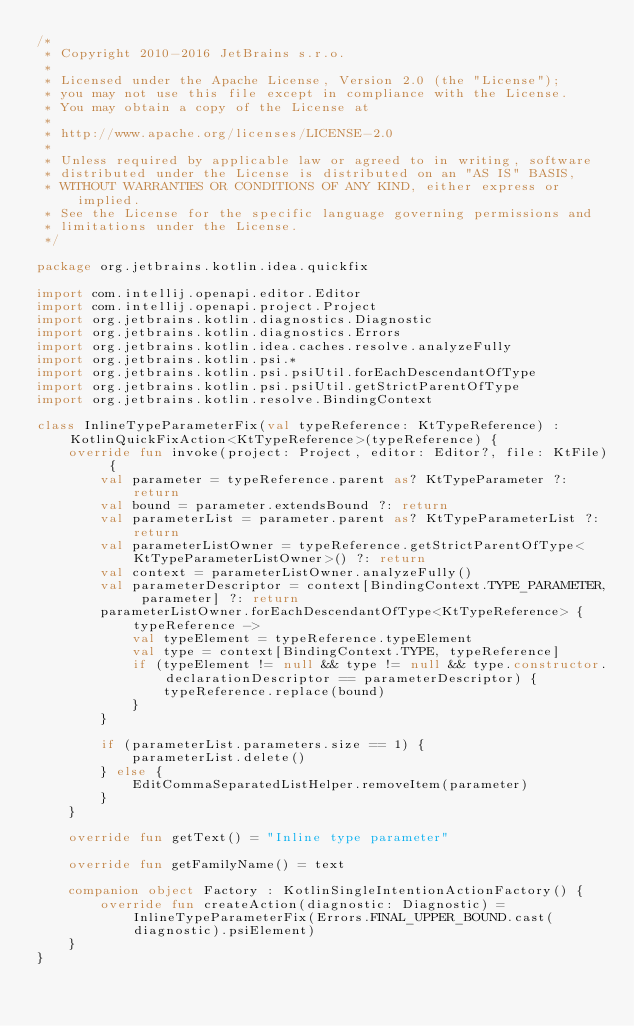Convert code to text. <code><loc_0><loc_0><loc_500><loc_500><_Kotlin_>/*
 * Copyright 2010-2016 JetBrains s.r.o.
 *
 * Licensed under the Apache License, Version 2.0 (the "License");
 * you may not use this file except in compliance with the License.
 * You may obtain a copy of the License at
 *
 * http://www.apache.org/licenses/LICENSE-2.0
 *
 * Unless required by applicable law or agreed to in writing, software
 * distributed under the License is distributed on an "AS IS" BASIS,
 * WITHOUT WARRANTIES OR CONDITIONS OF ANY KIND, either express or implied.
 * See the License for the specific language governing permissions and
 * limitations under the License.
 */

package org.jetbrains.kotlin.idea.quickfix

import com.intellij.openapi.editor.Editor
import com.intellij.openapi.project.Project
import org.jetbrains.kotlin.diagnostics.Diagnostic
import org.jetbrains.kotlin.diagnostics.Errors
import org.jetbrains.kotlin.idea.caches.resolve.analyzeFully
import org.jetbrains.kotlin.psi.*
import org.jetbrains.kotlin.psi.psiUtil.forEachDescendantOfType
import org.jetbrains.kotlin.psi.psiUtil.getStrictParentOfType
import org.jetbrains.kotlin.resolve.BindingContext

class InlineTypeParameterFix(val typeReference: KtTypeReference) : KotlinQuickFixAction<KtTypeReference>(typeReference) {
    override fun invoke(project: Project, editor: Editor?, file: KtFile) {
        val parameter = typeReference.parent as? KtTypeParameter ?: return
        val bound = parameter.extendsBound ?: return
        val parameterList = parameter.parent as? KtTypeParameterList ?: return
        val parameterListOwner = typeReference.getStrictParentOfType<KtTypeParameterListOwner>() ?: return
        val context = parameterListOwner.analyzeFully()
        val parameterDescriptor = context[BindingContext.TYPE_PARAMETER, parameter] ?: return
        parameterListOwner.forEachDescendantOfType<KtTypeReference> { typeReference ->
            val typeElement = typeReference.typeElement
            val type = context[BindingContext.TYPE, typeReference]
            if (typeElement != null && type != null && type.constructor.declarationDescriptor == parameterDescriptor) {
                typeReference.replace(bound)
            }
        }

        if (parameterList.parameters.size == 1) {
            parameterList.delete()
        } else {
            EditCommaSeparatedListHelper.removeItem(parameter)
        }
    }

    override fun getText() = "Inline type parameter"

    override fun getFamilyName() = text

    companion object Factory : KotlinSingleIntentionActionFactory() {
        override fun createAction(diagnostic: Diagnostic) = InlineTypeParameterFix(Errors.FINAL_UPPER_BOUND.cast(diagnostic).psiElement)
    }
}</code> 